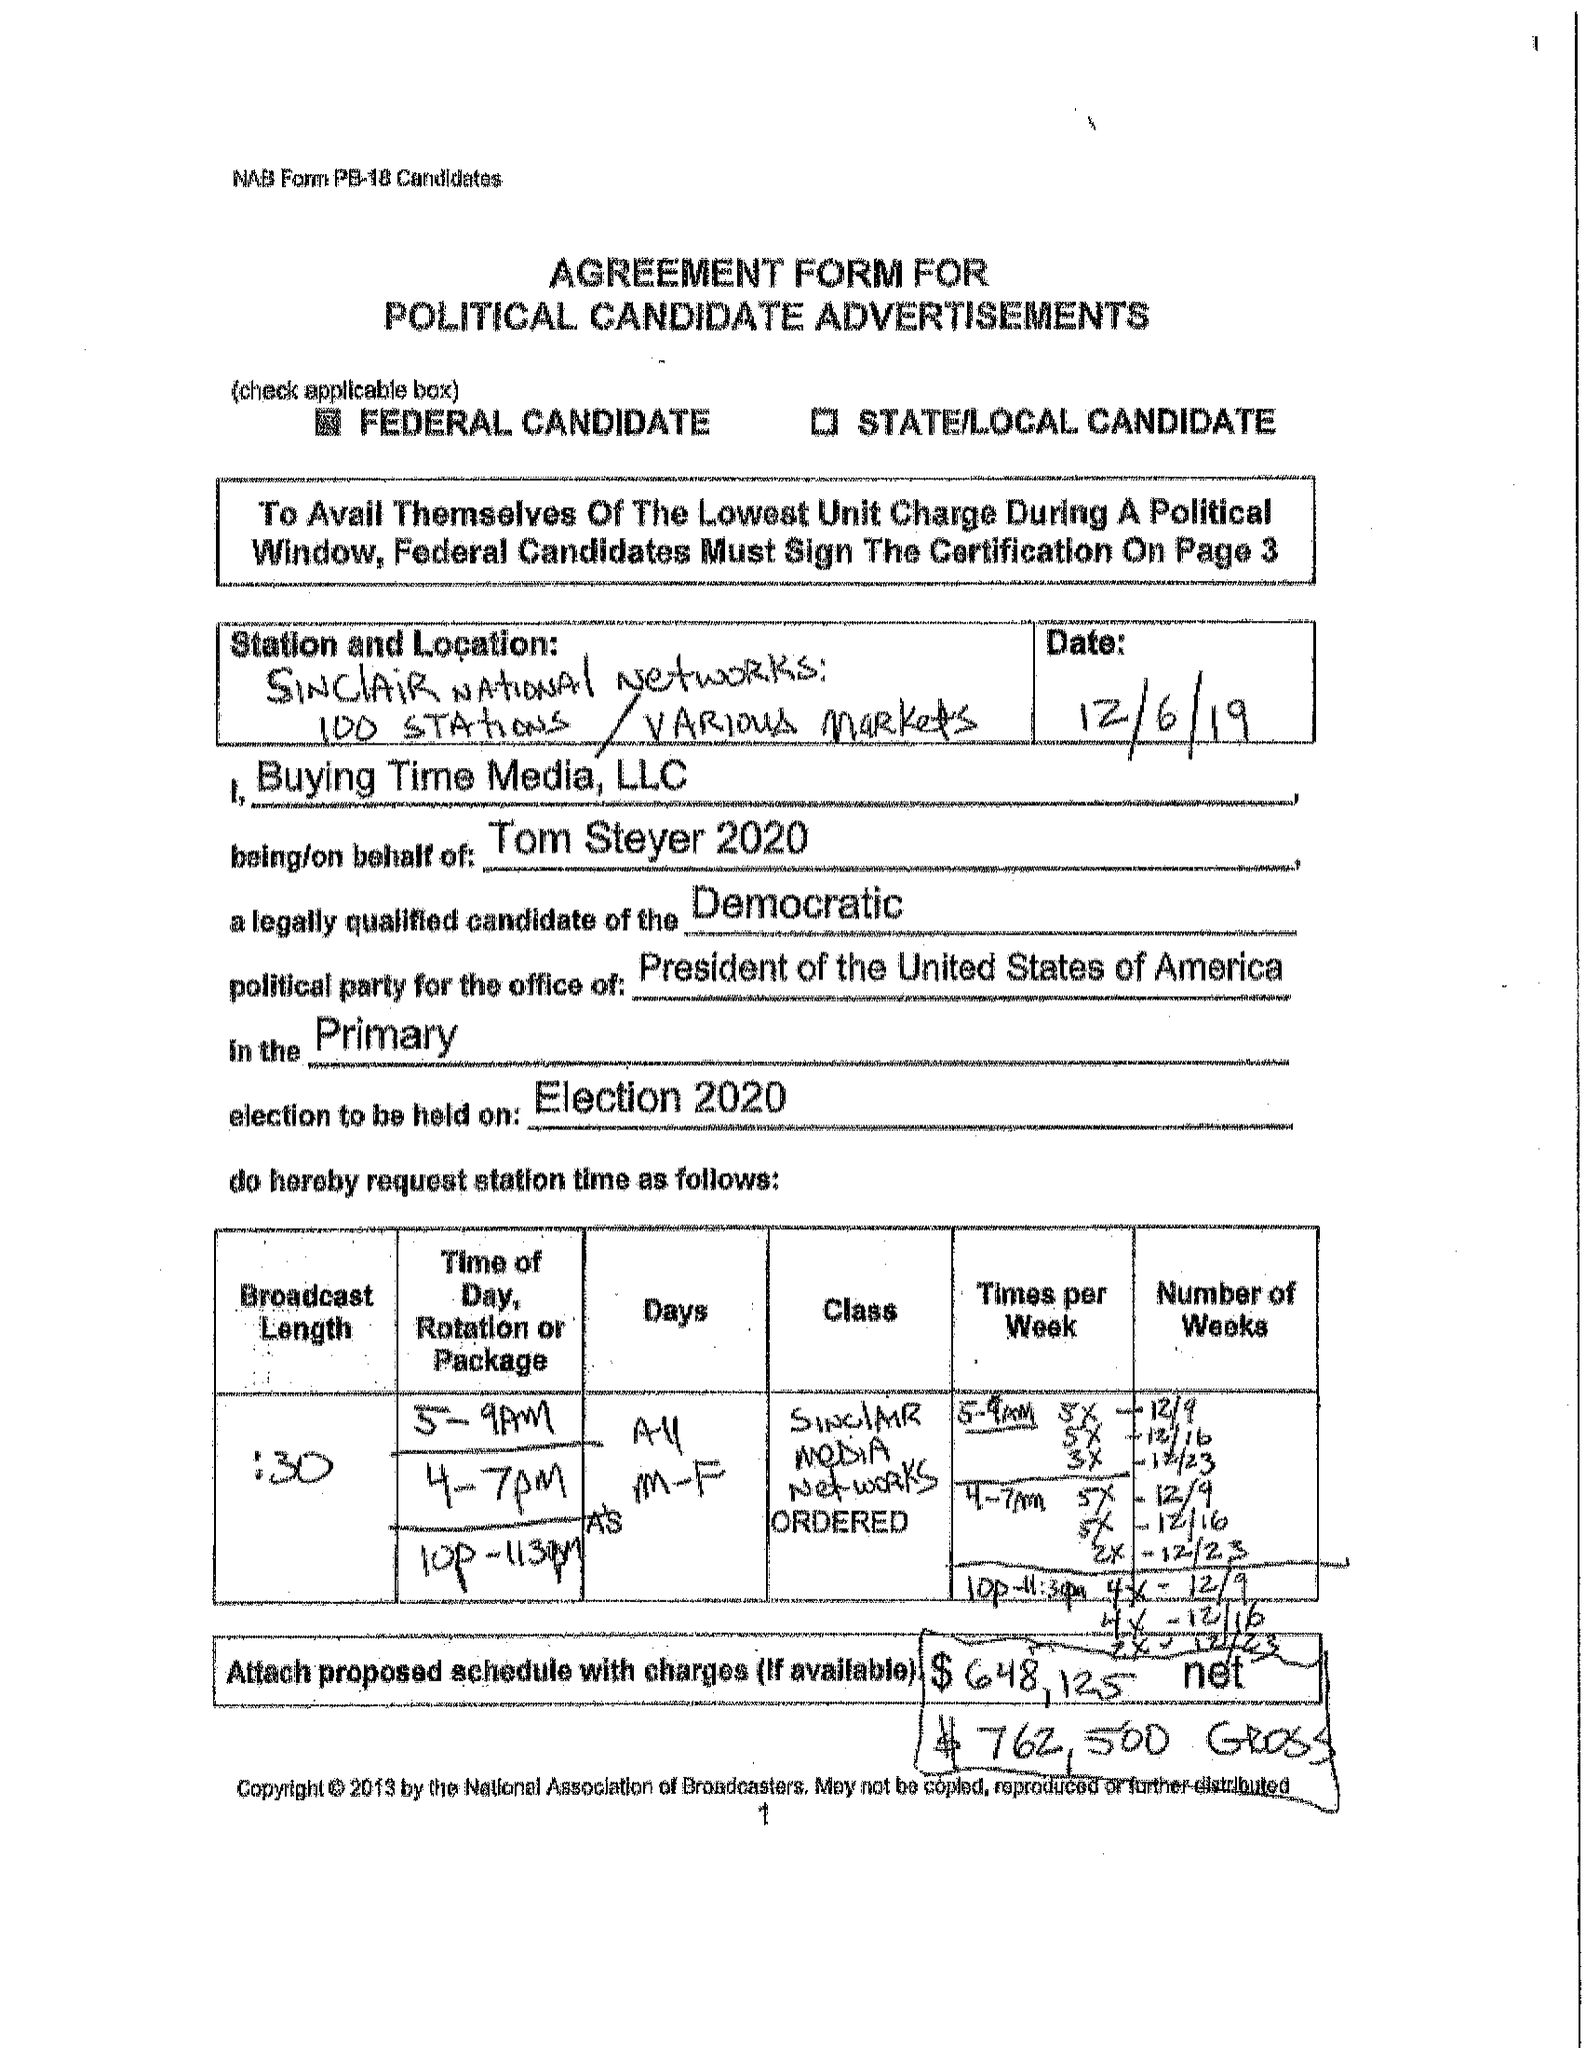What is the value for the gross_amount?
Answer the question using a single word or phrase. 762500.00 